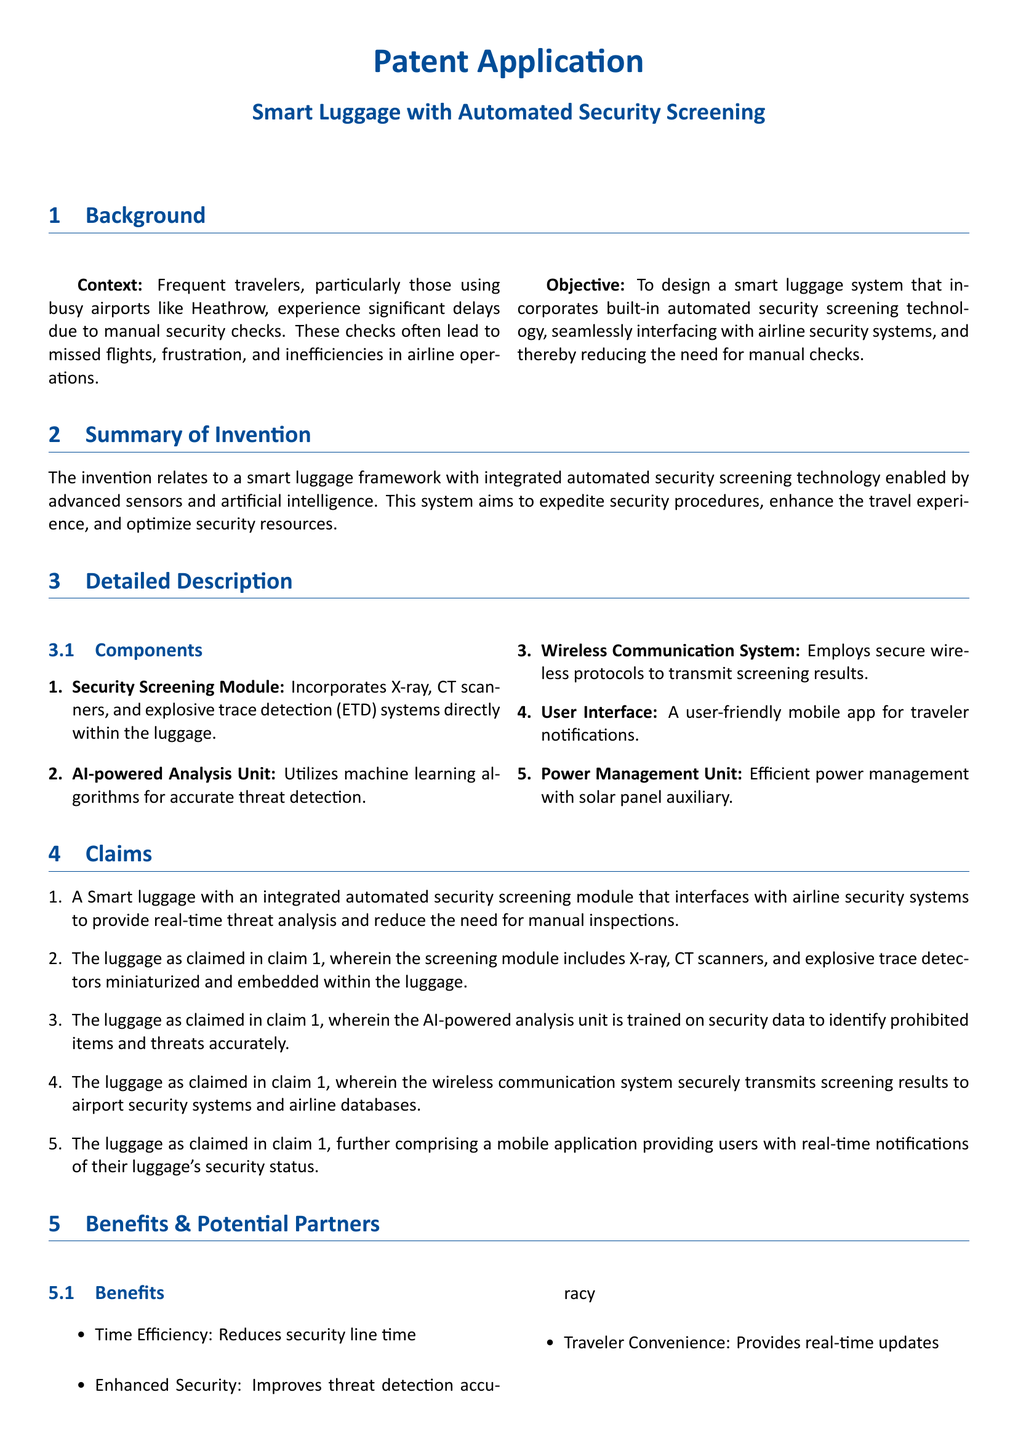What is the title of the patent application? The title of the patent application is specified in the header section of the document.
Answer: Smart Luggage with Automated Security Screening What is the main objective of the invention? The objective is mentioned in the Background section of the document.
Answer: To design a smart luggage system that incorporates built-in automated security screening technology How many components are listed in the detailed description? The number of components can be found in the Detailed Description section where they are enumerated.
Answer: Five Which advanced technology is used for threat detection in the luggage? The technology used for threat detection is detailed in the components section.
Answer: AI-powered Analysis Unit Who is a potential partner for scanning technologies? The potential partners and their roles are listed in the Benefits & Potential Partners section.
Answer: Siemens What feature provides users with real-time notifications? This feature is mentioned in the Benefits & Potential Partners section, under the user interface.
Answer: Mobile application What do the screening results transmit to? The screening results transmission is described in the claims section.
Answer: Airport security systems and airline databases What benefit is related to reducing security line time? The benefits are listed in the Benefits section of the document.
Answer: Time Efficiency Which company is involved in AI hardware and algorithms? This information is available under the Potential Partners section.
Answer: NVIDIA 